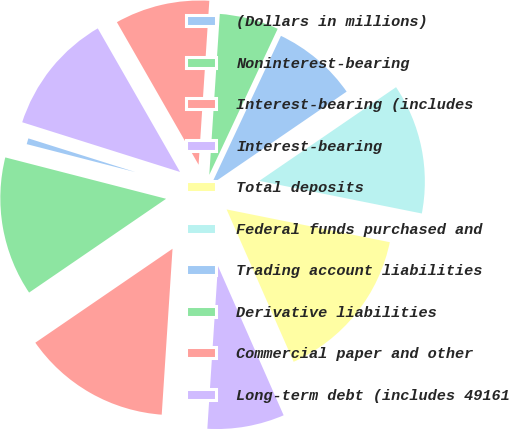Convert chart to OTSL. <chart><loc_0><loc_0><loc_500><loc_500><pie_chart><fcel>(Dollars in millions)<fcel>Noninterest-bearing<fcel>Interest-bearing (includes<fcel>Interest-bearing<fcel>Total deposits<fcel>Federal funds purchased and<fcel>Trading account liabilities<fcel>Derivative liabilities<fcel>Commercial paper and other<fcel>Long-term debt (includes 49161<nl><fcel>0.85%<fcel>13.56%<fcel>14.41%<fcel>7.63%<fcel>15.25%<fcel>12.71%<fcel>8.47%<fcel>5.93%<fcel>9.32%<fcel>11.86%<nl></chart> 